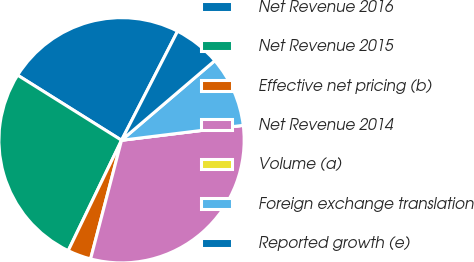Convert chart to OTSL. <chart><loc_0><loc_0><loc_500><loc_500><pie_chart><fcel>Net Revenue 2016<fcel>Net Revenue 2015<fcel>Effective net pricing (b)<fcel>Net Revenue 2014<fcel>Volume (a)<fcel>Foreign exchange translation<fcel>Reported growth (e)<nl><fcel>23.64%<fcel>26.74%<fcel>3.1%<fcel>31.0%<fcel>0.0%<fcel>9.3%<fcel>6.2%<nl></chart> 